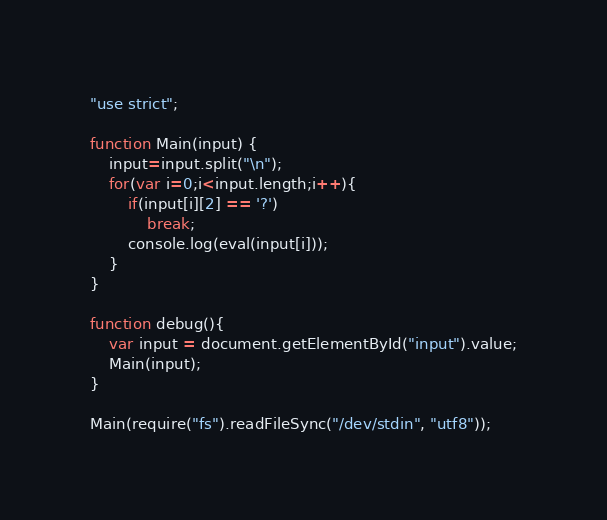<code> <loc_0><loc_0><loc_500><loc_500><_JavaScript_>"use strict";

function Main(input) {
    input=input.split("\n");
    for(var i=0;i<input.length;i++){
        if(input[i][2] == '?')
            break;
        console.log(eval(input[i]));
    }
}
    
function debug(){
	var input = document.getElementById("input").value;
	Main(input);
}

Main(require("fs").readFileSync("/dev/stdin", "utf8"));</code> 